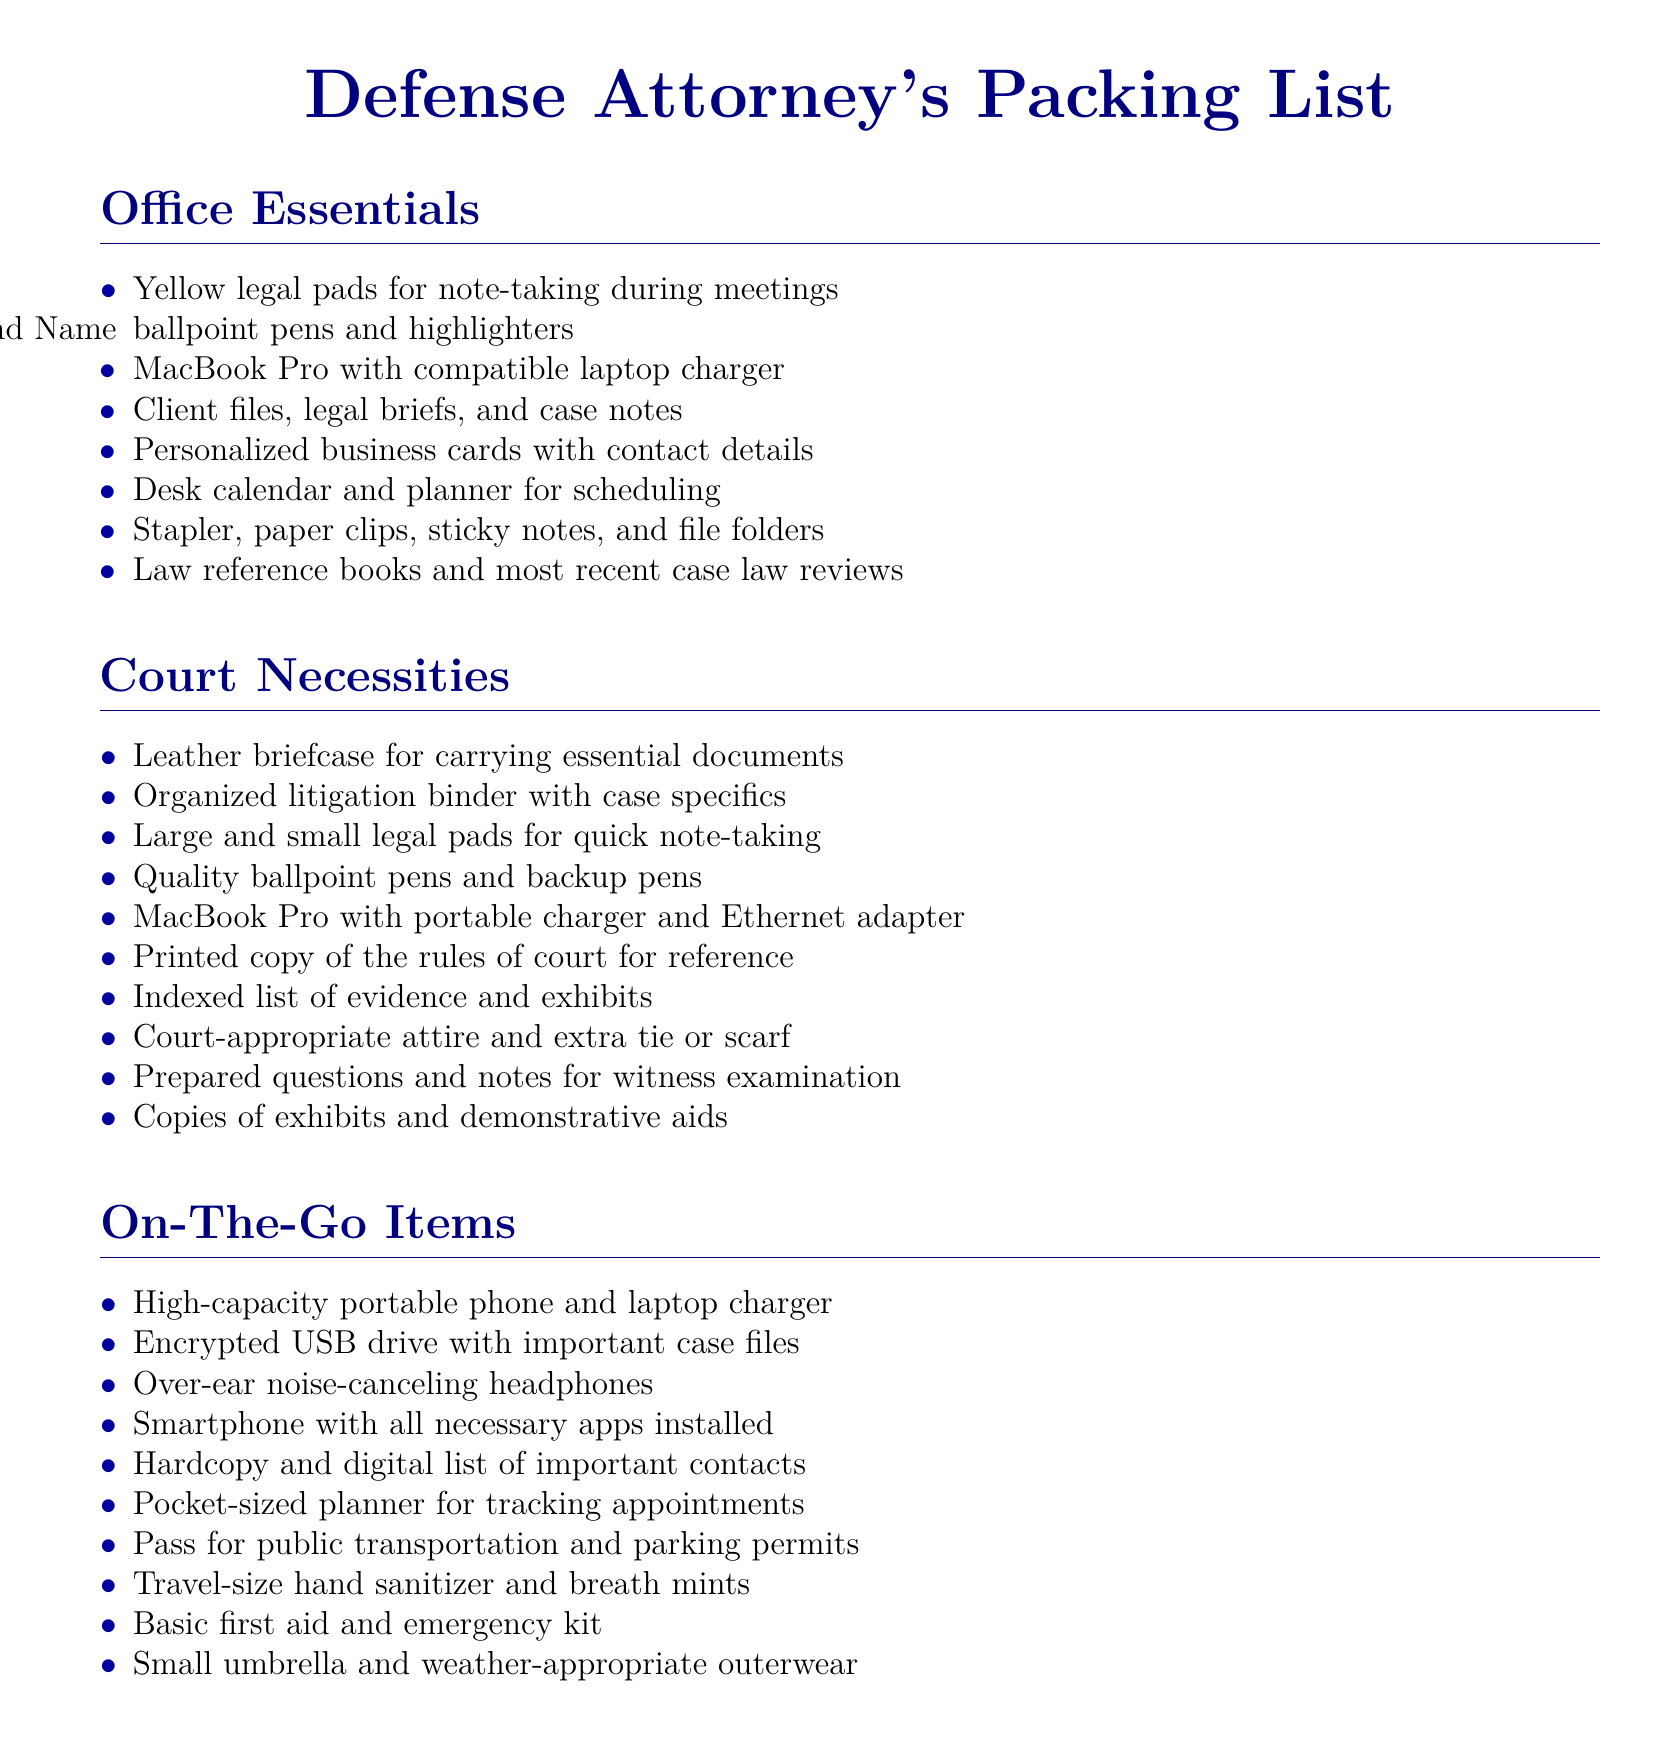What is the title of the document? The title of the document is displayed prominently at the top and is "Defense Attorney's Packing List."
Answer: Defense Attorney's Packing List How many sections are there in the packing list? The packing list contains three sections: Office Essentials, Court Necessities, and On-The-Go Items.
Answer: Three What item is included for note-taking in court? The document lists both large and small legal pads as items for quick note-taking during court.
Answer: Large and small legal pads What type of charger is mentioned for the MacBook Pro? The document mentions a compatible laptop charger and a portable charger specifically for use in court.
Answer: Compatible laptop charger and portable charger Which essential item is recommended for legal reference? Law reference books and most recent case law reviews are included as necessary items for legal reference.
Answer: Law reference books What is a suggested item for keeping track of appointments? The packing list includes a pocket-sized planner for tracking appointments while on the go.
Answer: Pocket-sized planner What type of attire is recommended for court? The packing list specifies court-appropriate attire as a necessary item.
Answer: Court-appropriate attire What emergency item is suggested for on-the-go use? A basic first aid and emergency kit is suggested for use while on the go.
Answer: Basic first aid and emergency kit How many items are listed under On-The-Go Items? There are ten items listed under the On-The-Go Items section of the packing list.
Answer: Ten items 